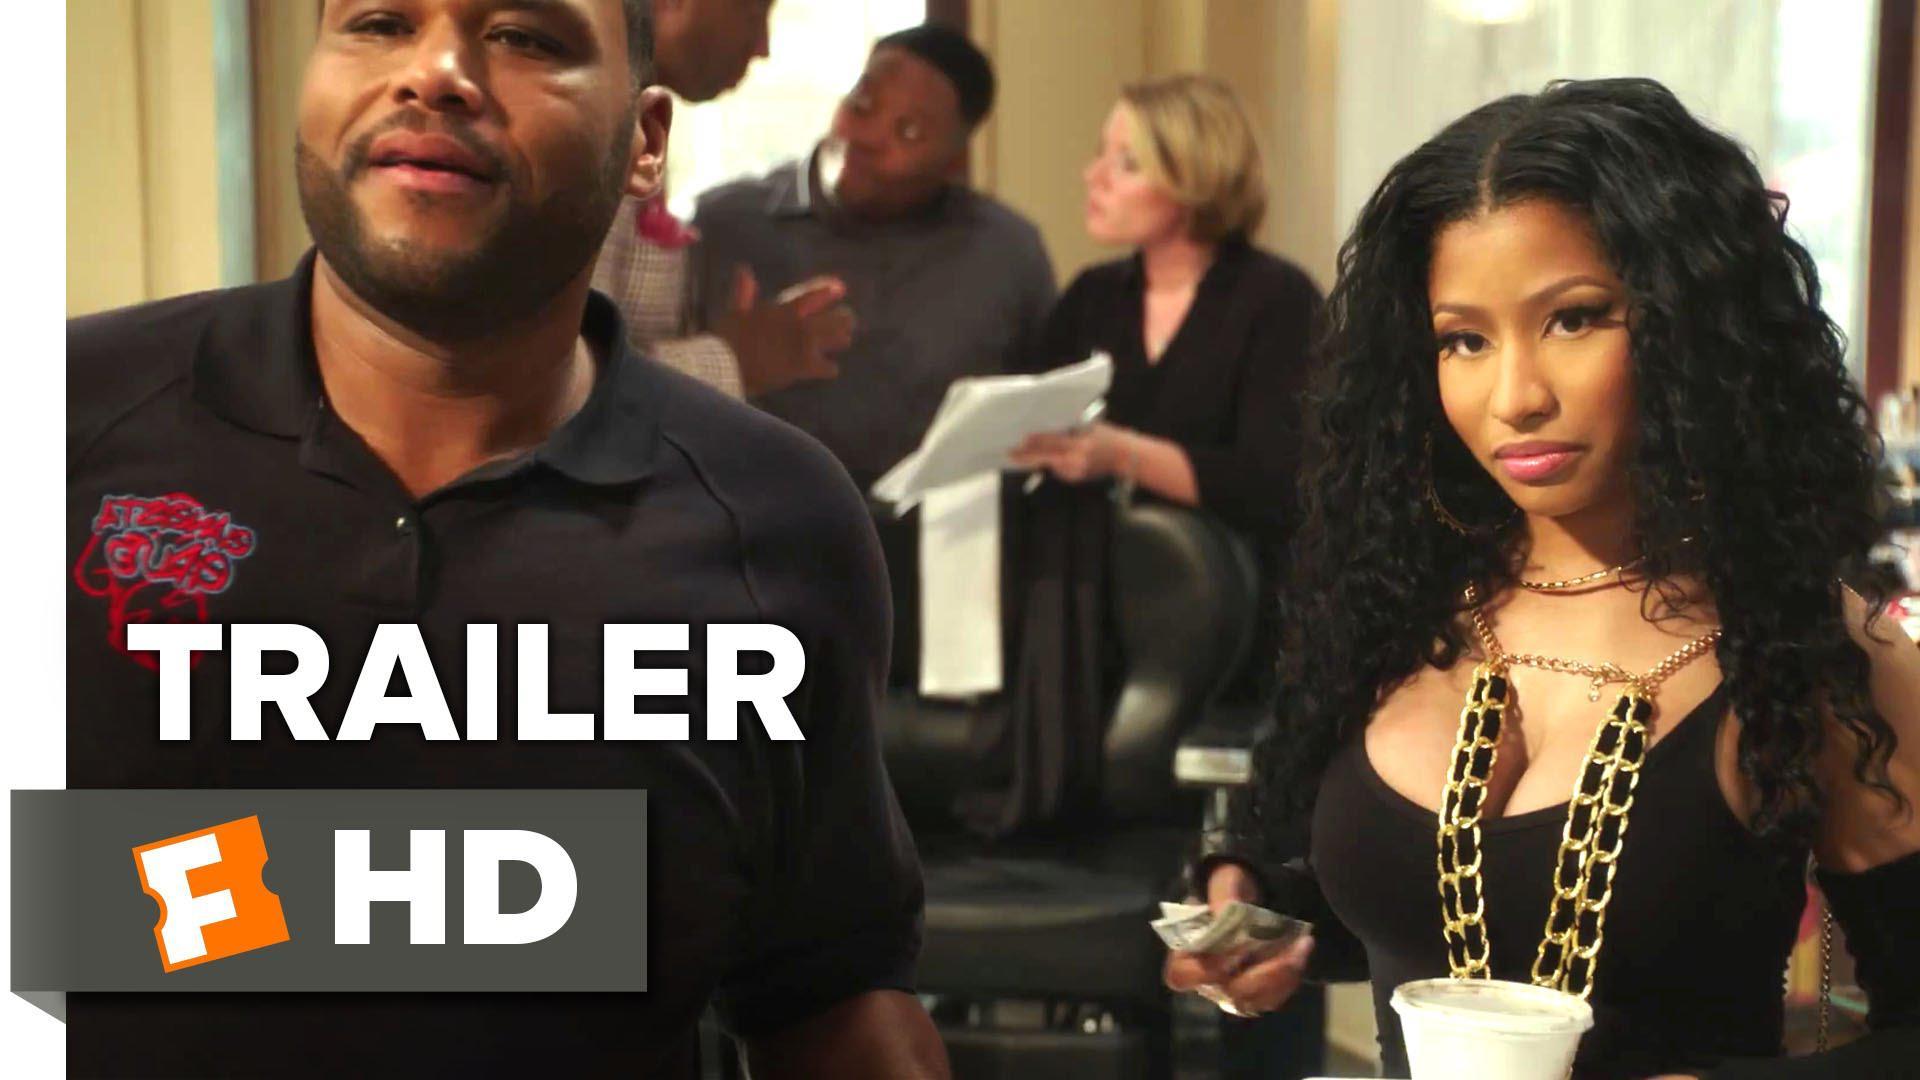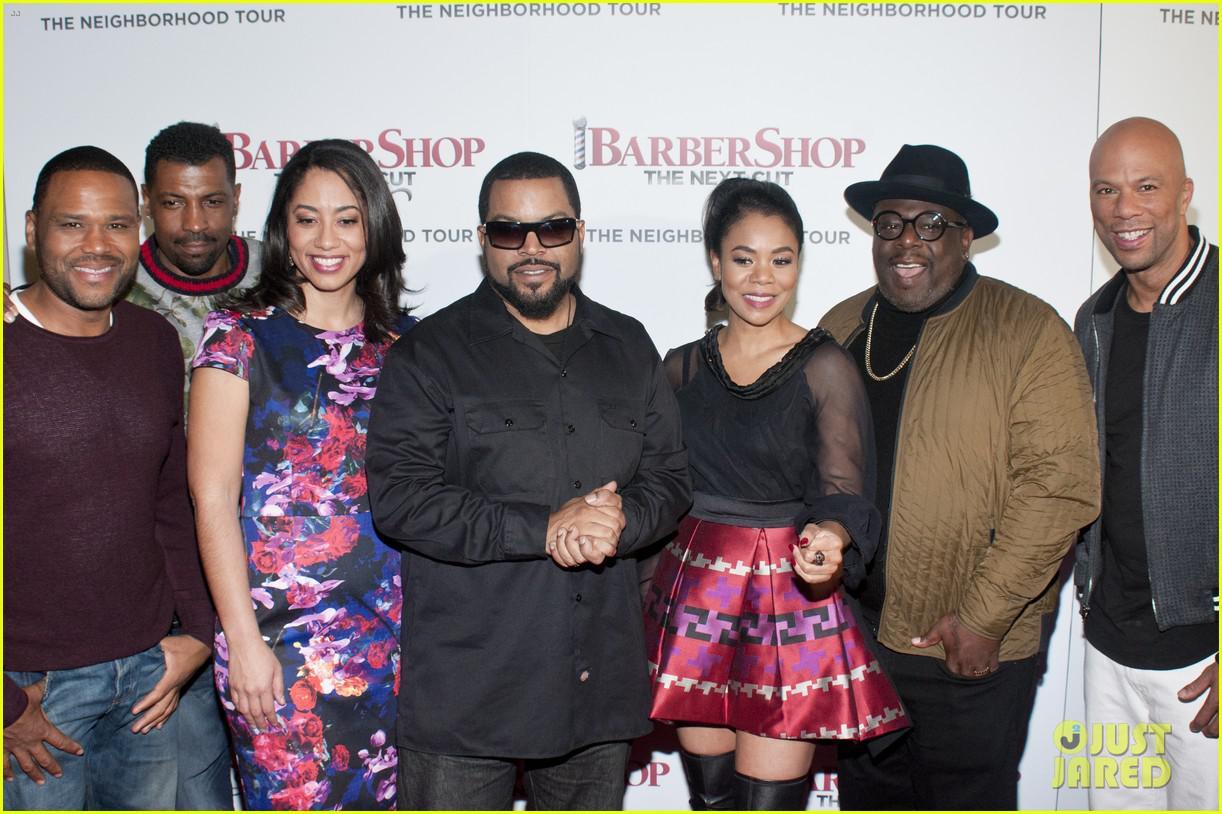The first image is the image on the left, the second image is the image on the right. Examine the images to the left and right. Is the description "The person in the right image furthest to the right has a bald scalp." accurate? Answer yes or no. Yes. The first image is the image on the left, the second image is the image on the right. For the images shown, is this caption "There is at least one image of a man sitting in a barber chair." true? Answer yes or no. No. 